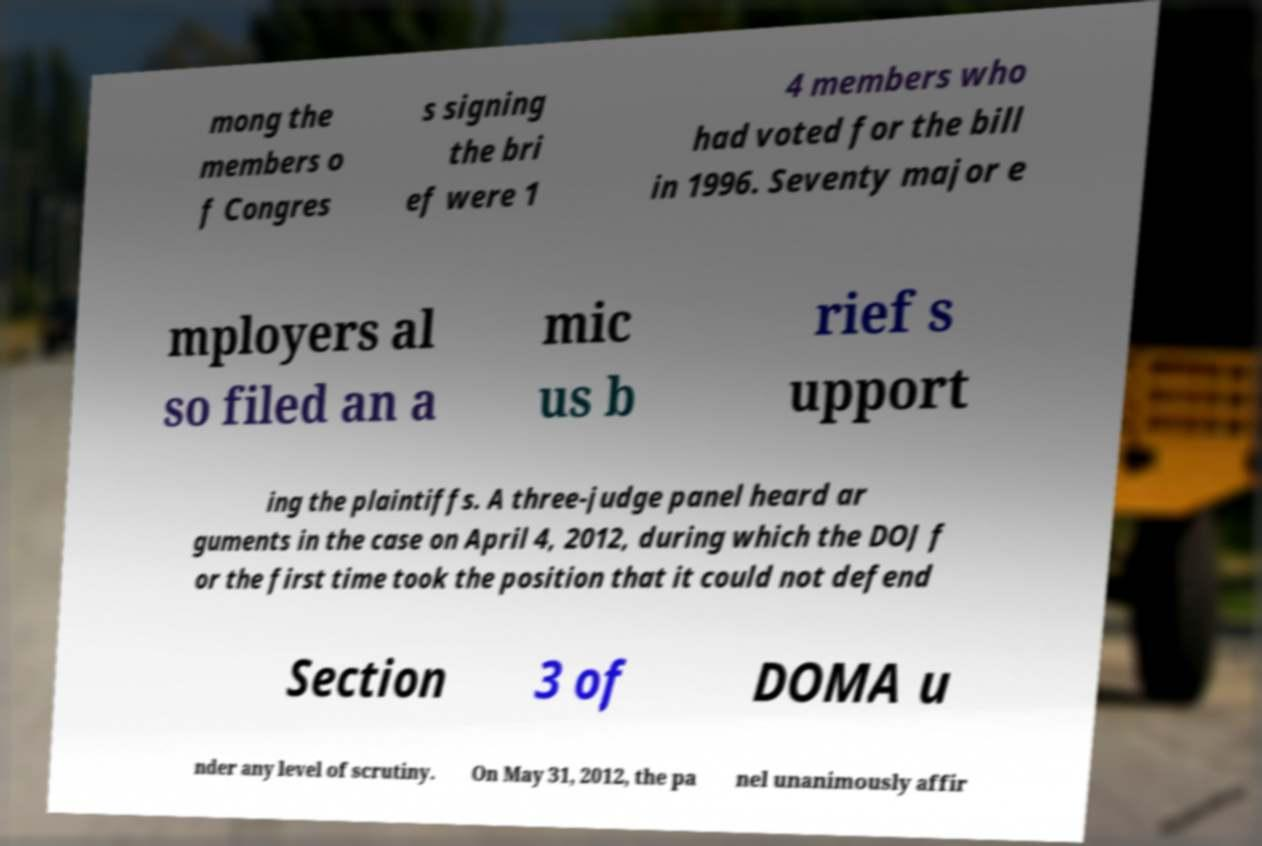For documentation purposes, I need the text within this image transcribed. Could you provide that? mong the members o f Congres s signing the bri ef were 1 4 members who had voted for the bill in 1996. Seventy major e mployers al so filed an a mic us b rief s upport ing the plaintiffs. A three-judge panel heard ar guments in the case on April 4, 2012, during which the DOJ f or the first time took the position that it could not defend Section 3 of DOMA u nder any level of scrutiny. On May 31, 2012, the pa nel unanimously affir 